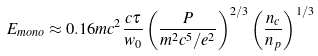Convert formula to latex. <formula><loc_0><loc_0><loc_500><loc_500>E _ { m o n o } \approx 0 . 1 6 m c ^ { 2 } \frac { c \tau } { w _ { 0 } } \left ( \frac { P } { m ^ { 2 } c ^ { 5 } / e ^ { 2 } } \right ) ^ { 2 / 3 } \left ( \frac { n _ { c } } { n _ { p } } \right ) ^ { 1 / 3 }</formula> 